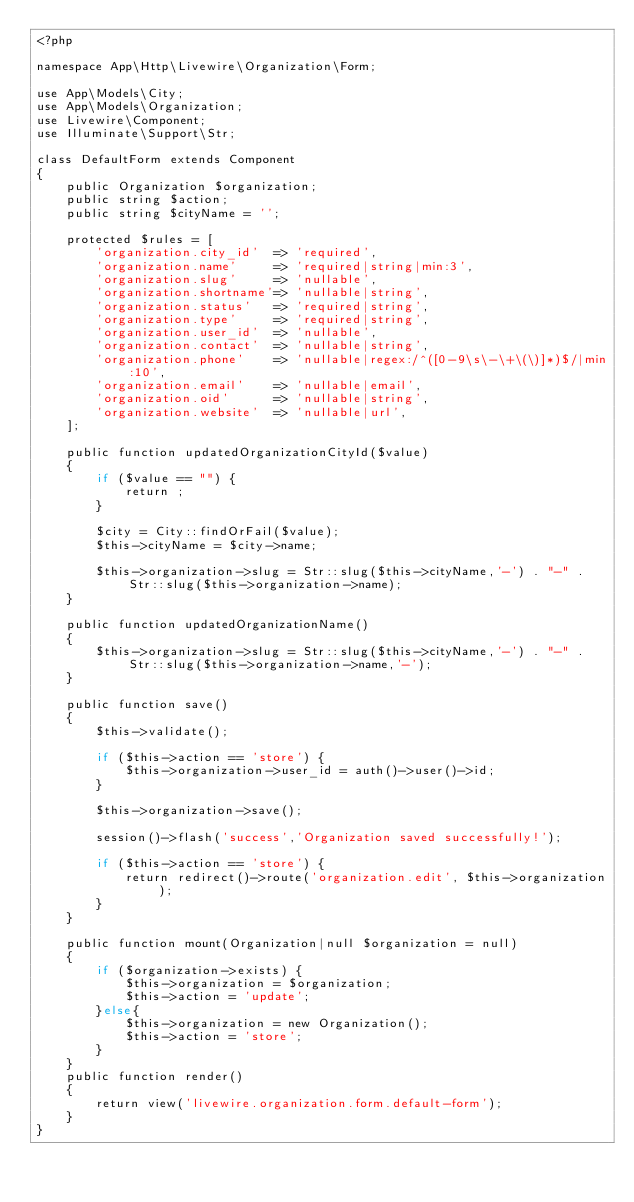<code> <loc_0><loc_0><loc_500><loc_500><_PHP_><?php

namespace App\Http\Livewire\Organization\Form;

use App\Models\City;
use App\Models\Organization;
use Livewire\Component;
use Illuminate\Support\Str;

class DefaultForm extends Component
{
    public Organization $organization;
    public string $action;
    public string $cityName = '';

    protected $rules = [
        'organization.city_id'  => 'required',
        'organization.name'     => 'required|string|min:3',
        'organization.slug'     => 'nullable',
        'organization.shortname'=> 'nullable|string',
        'organization.status'   => 'required|string',
        'organization.type'     => 'required|string',
        'organization.user_id'  => 'nullable',
        'organization.contact'  => 'nullable|string',
        'organization.phone'    => 'nullable|regex:/^([0-9\s\-\+\(\)]*)$/|min:10',
        'organization.email'    => 'nullable|email',
        'organization.oid'      => 'nullable|string',
        'organization.website'  => 'nullable|url',
    ];

    public function updatedOrganizationCityId($value)
    {
        if ($value == "") {
            return ;
        }
                
        $city = City::findOrFail($value);            
        $this->cityName = $city->name;         
         
        $this->organization->slug = Str::slug($this->cityName,'-') . "-" . Str::slug($this->organization->name);
    }

    public function updatedOrganizationName()
    {
        $this->organization->slug = Str::slug($this->cityName,'-') . "-" . Str::slug($this->organization->name,'-');
    }

    public function save()
    {
        $this->validate();

        if ($this->action == 'store') {
            $this->organization->user_id = auth()->user()->id;
        }
        
        $this->organization->save();

        session()->flash('success','Organization saved successfully!');

        if ($this->action == 'store') {
            return redirect()->route('organization.edit', $this->organization);
        }
    }

    public function mount(Organization|null $organization = null)
    {
        if ($organization->exists) {
            $this->organization = $organization;   
            $this->action = 'update';         
        }else{
            $this->organization = new Organization();
            $this->action = 'store';
        }
    }
    public function render()
    {
        return view('livewire.organization.form.default-form');
    }
}</code> 